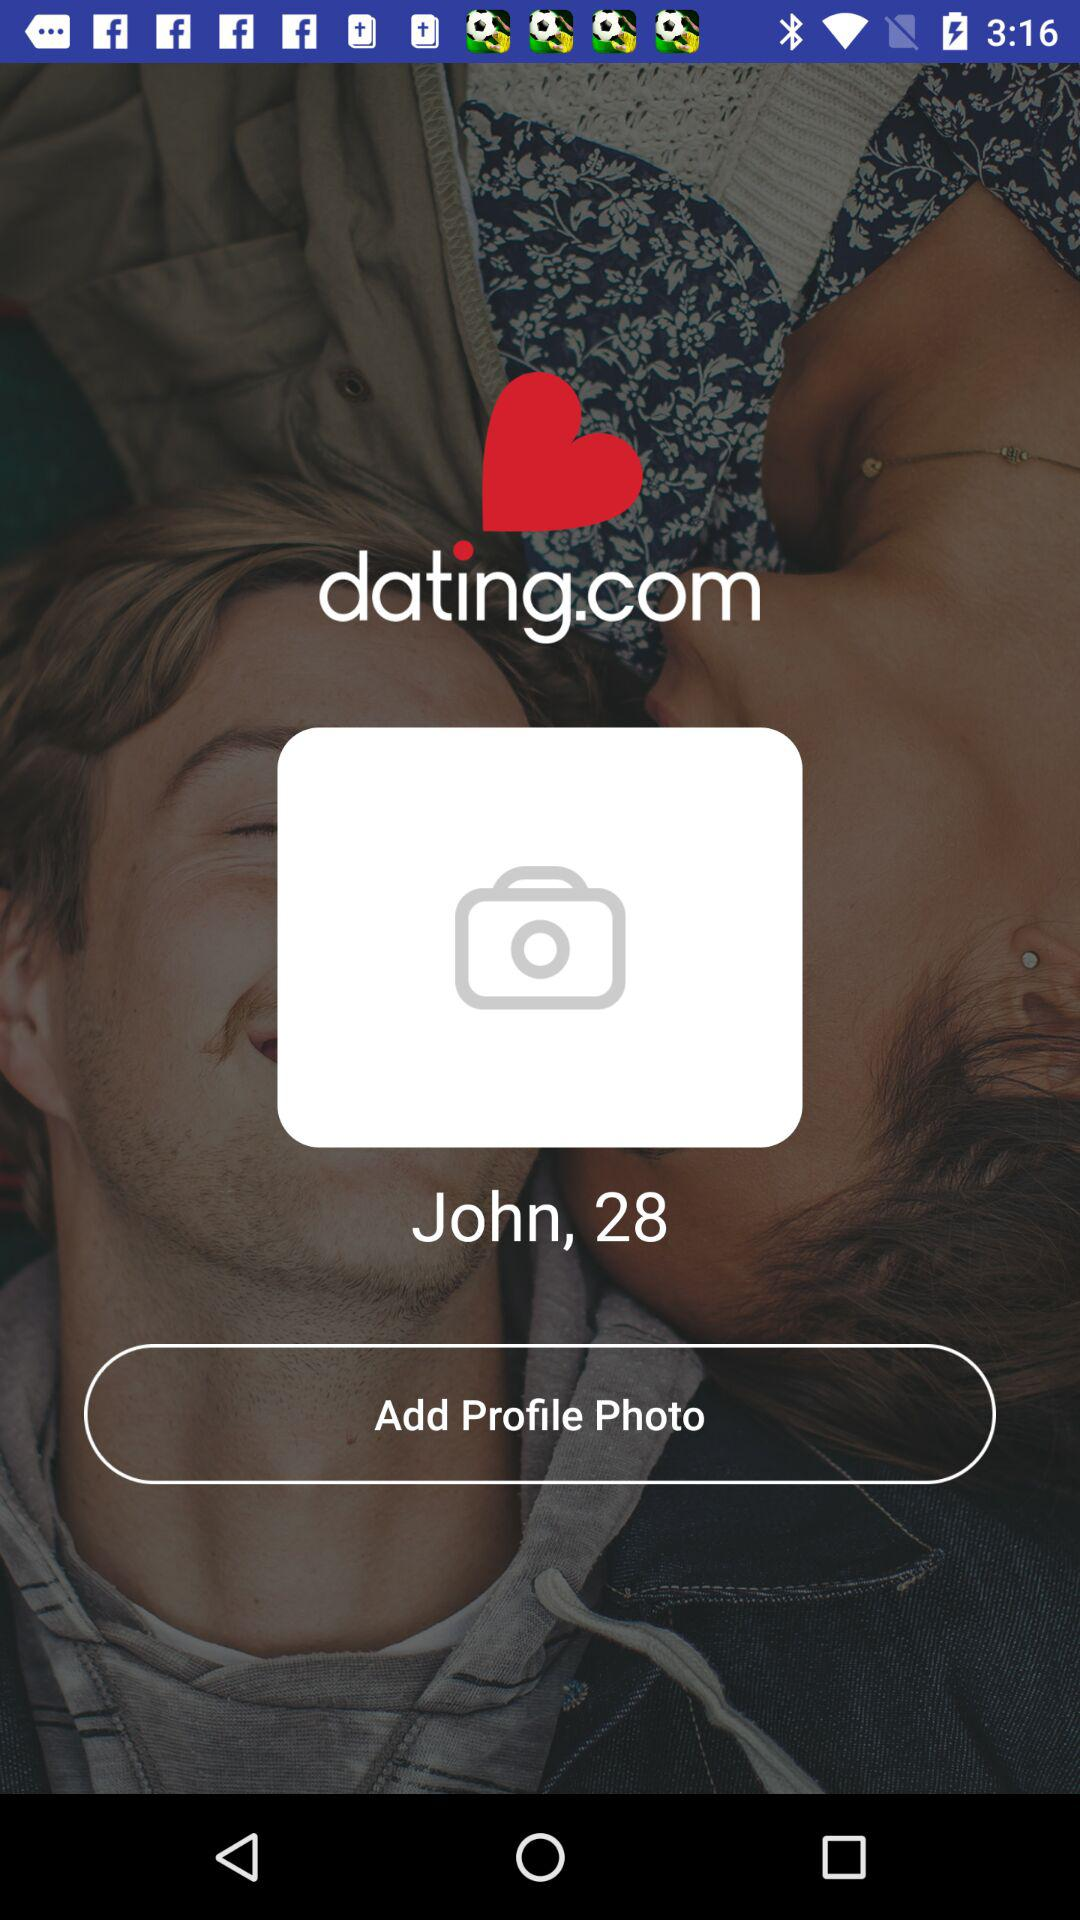What is the name of the user? The name of the user is John. 